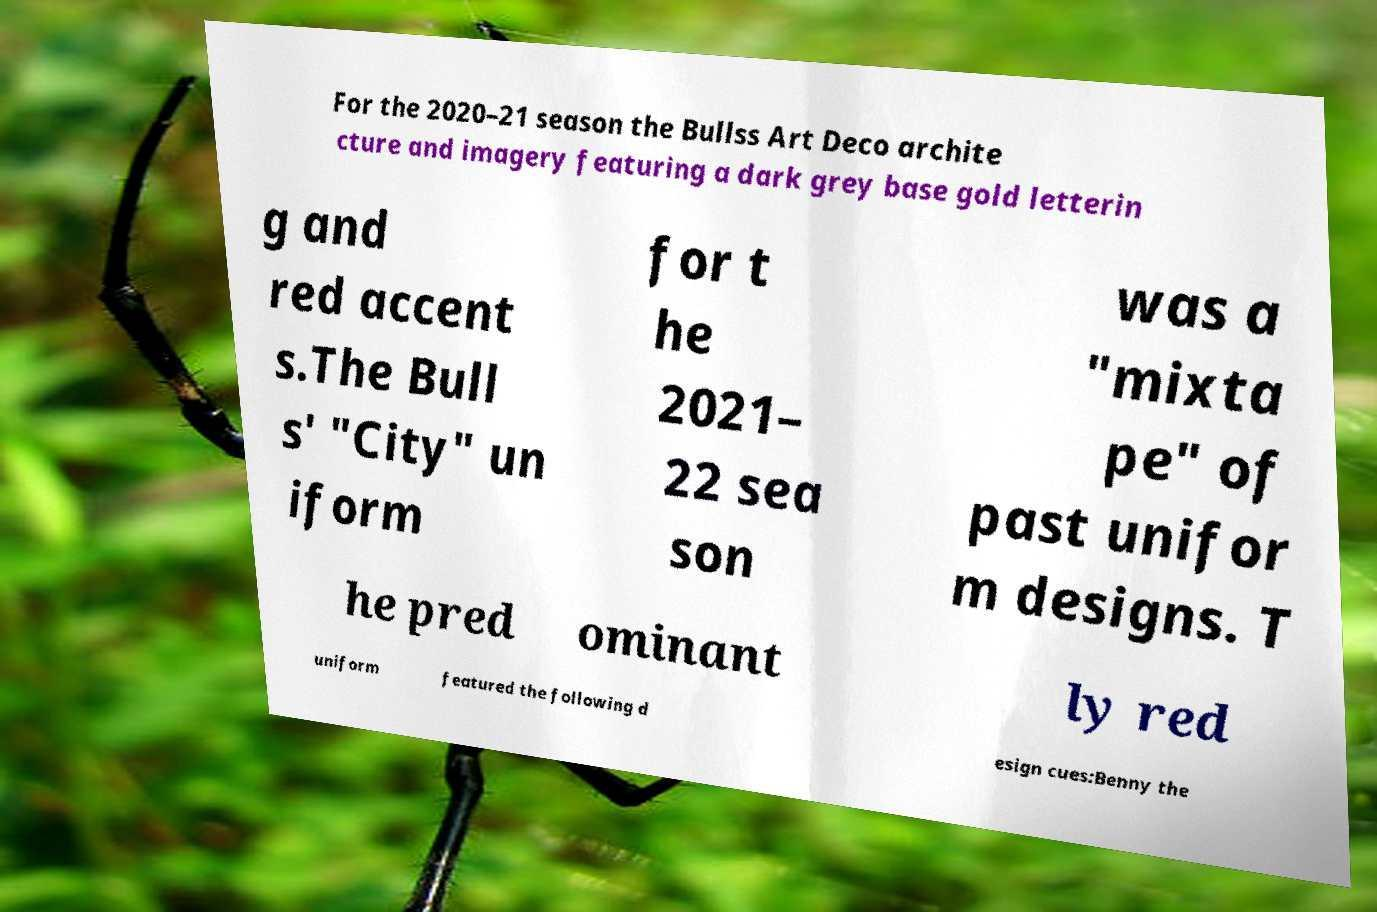Could you assist in decoding the text presented in this image and type it out clearly? For the 2020–21 season the Bullss Art Deco archite cture and imagery featuring a dark grey base gold letterin g and red accent s.The Bull s' "City" un iform for t he 2021– 22 sea son was a "mixta pe" of past unifor m designs. T he pred ominant ly red uniform featured the following d esign cues:Benny the 